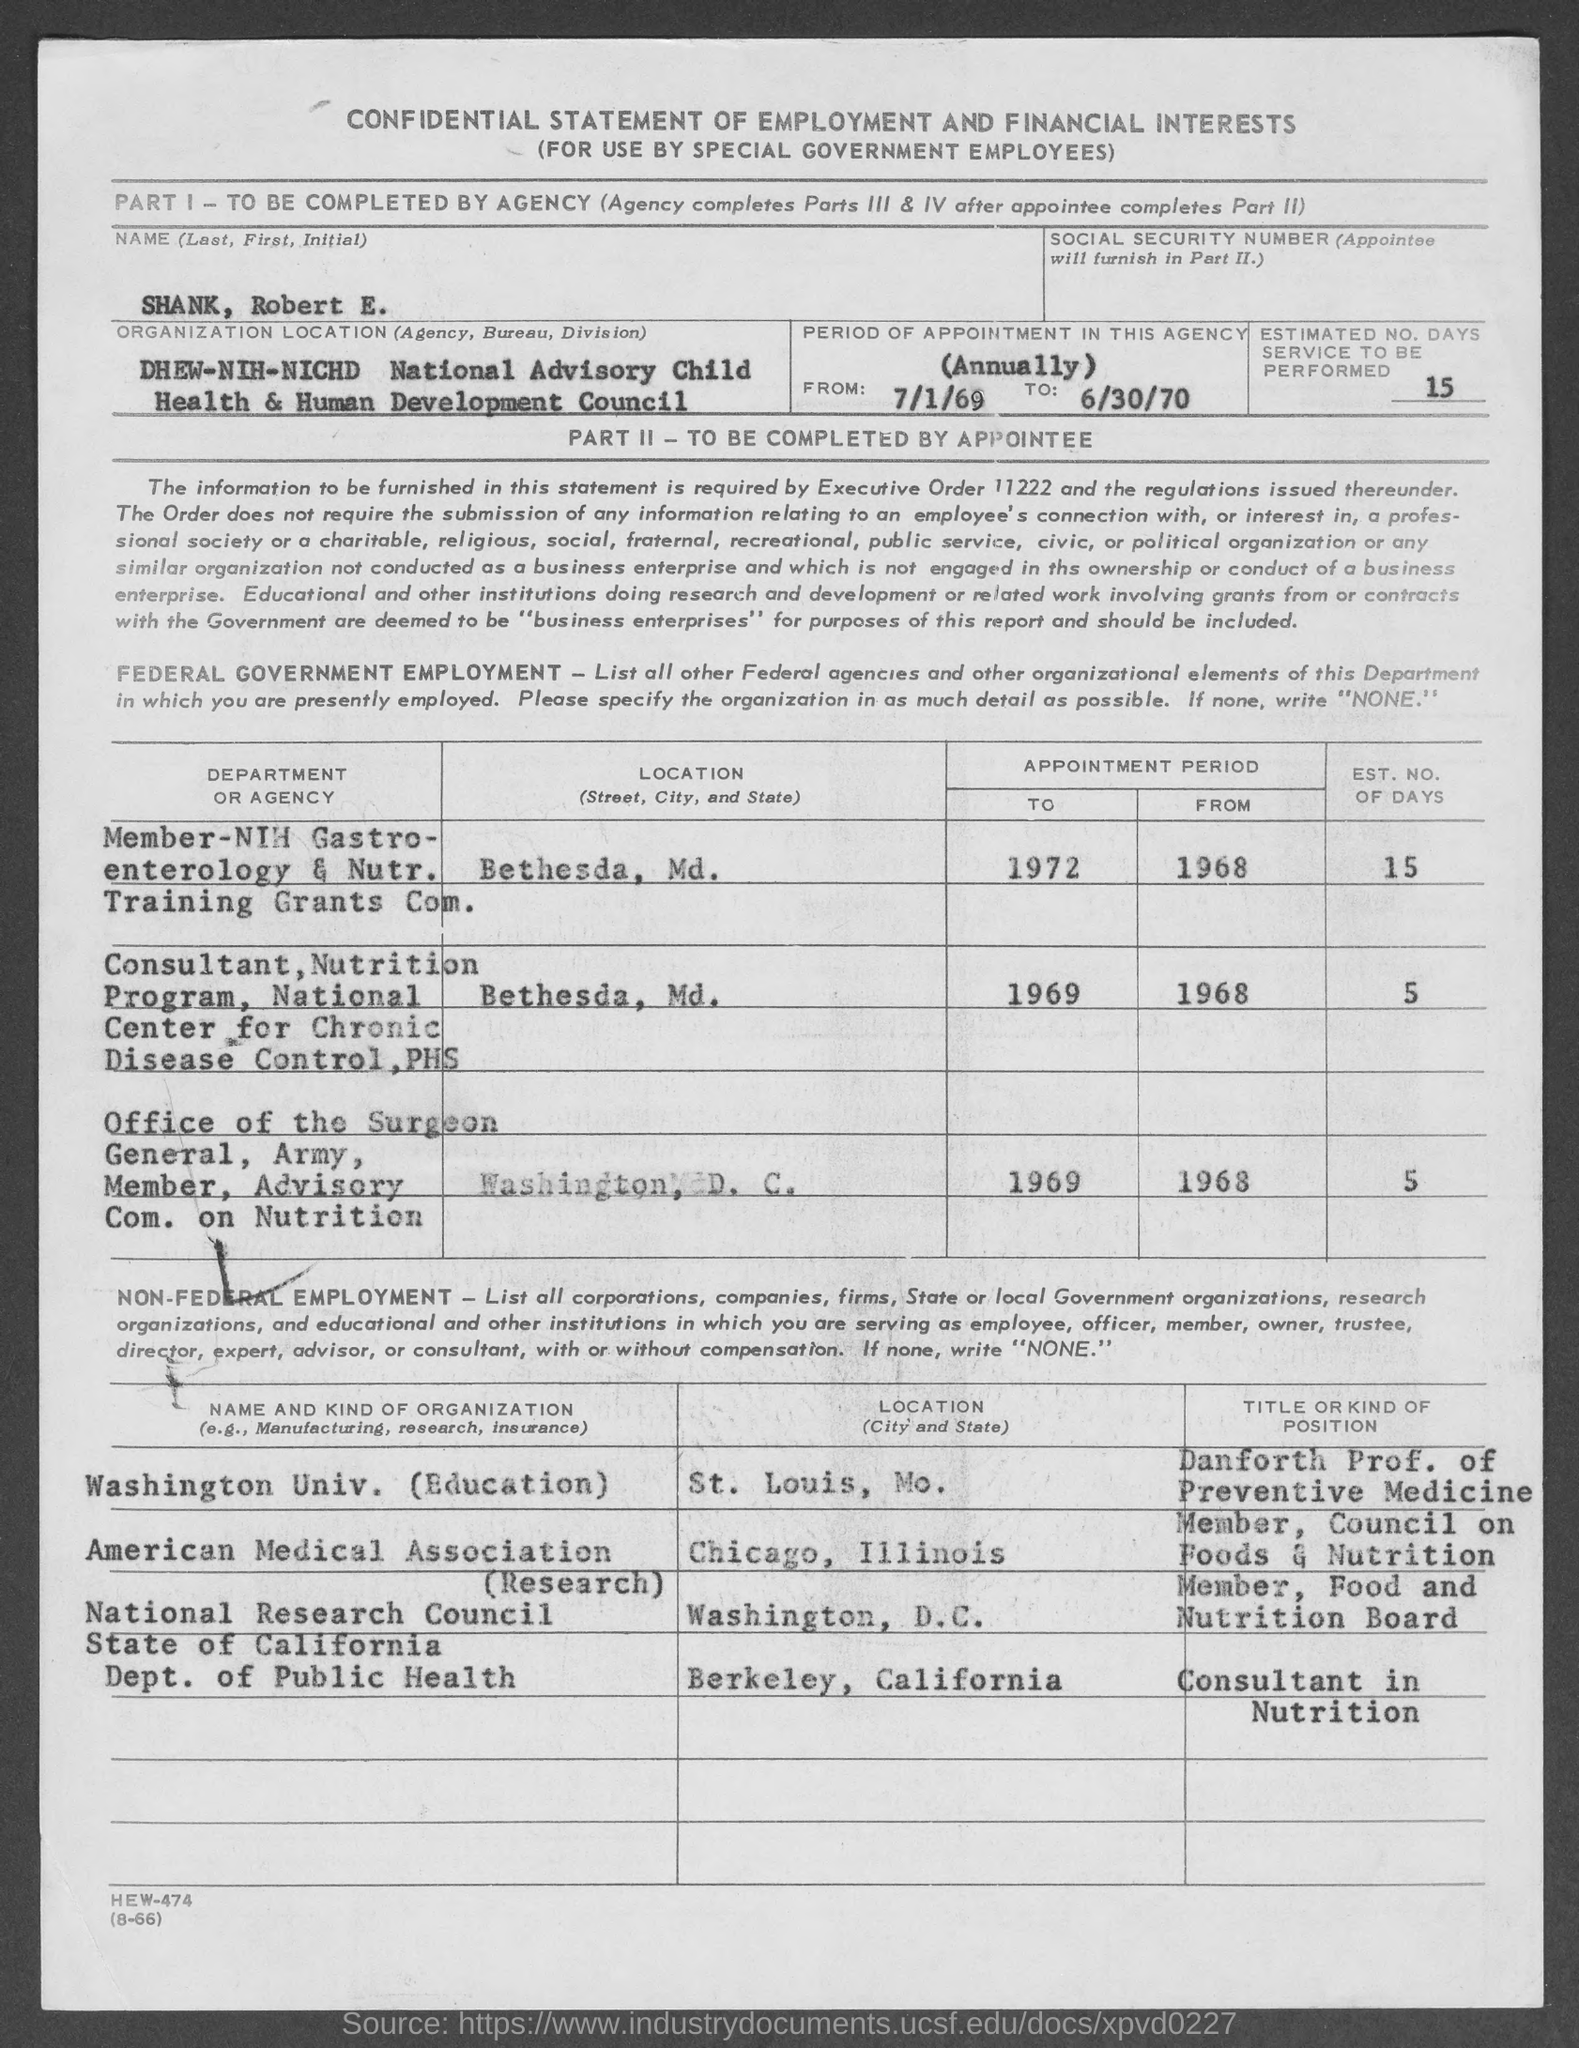Highlight a few significant elements in this photo. What is the estimated number of days that the service will be performed? 15.. The name is Robert E. Shank. 